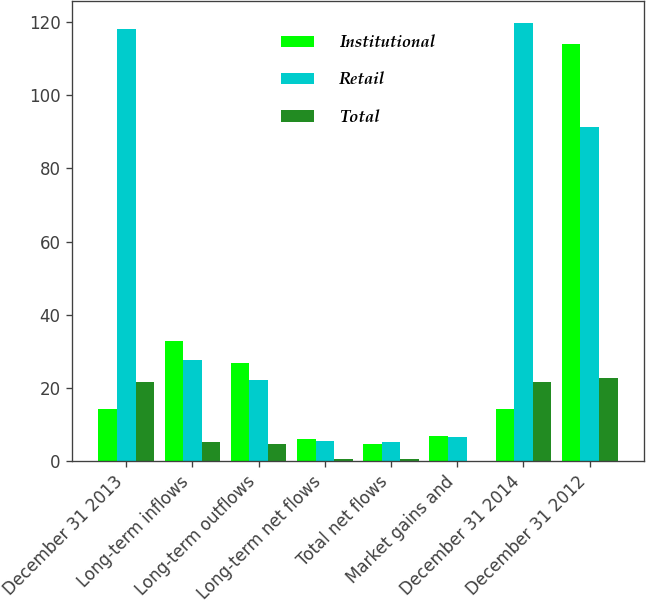Convert chart. <chart><loc_0><loc_0><loc_500><loc_500><stacked_bar_chart><ecel><fcel>December 31 2013<fcel>Long-term inflows<fcel>Long-term outflows<fcel>Long-term net flows<fcel>Total net flows<fcel>Market gains and<fcel>December 31 2014<fcel>December 31 2012<nl><fcel>Institutional<fcel>14.15<fcel>32.8<fcel>26.8<fcel>6<fcel>4.7<fcel>6.8<fcel>14.15<fcel>114<nl><fcel>Retail<fcel>118.2<fcel>27.7<fcel>22.2<fcel>5.5<fcel>5.2<fcel>6.7<fcel>119.7<fcel>91.2<nl><fcel>Total<fcel>21.5<fcel>5.1<fcel>4.6<fcel>0.5<fcel>0.5<fcel>0.1<fcel>21.7<fcel>22.8<nl></chart> 